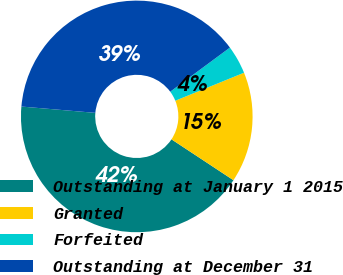Convert chart. <chart><loc_0><loc_0><loc_500><loc_500><pie_chart><fcel>Outstanding at January 1 2015<fcel>Granted<fcel>Forfeited<fcel>Outstanding at December 31<nl><fcel>42.07%<fcel>15.44%<fcel>3.97%<fcel>38.51%<nl></chart> 